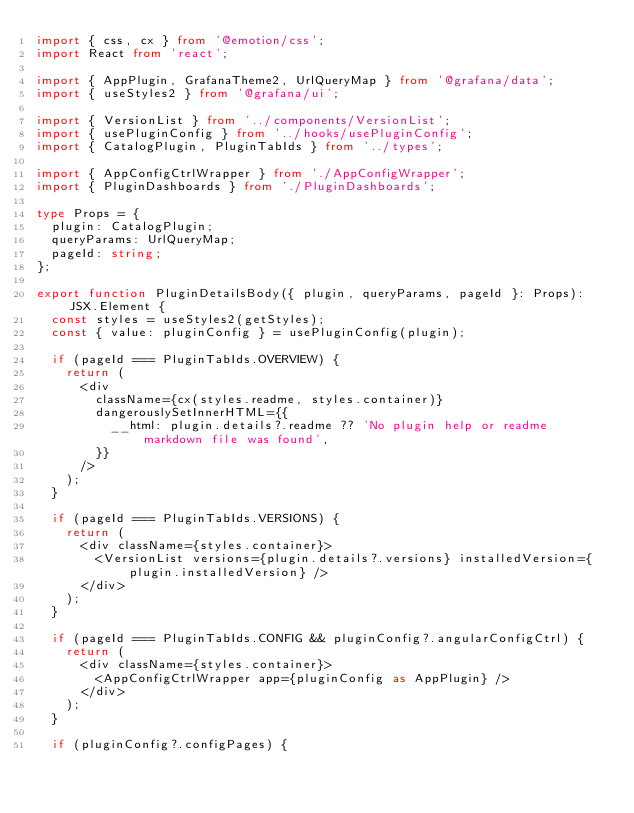Convert code to text. <code><loc_0><loc_0><loc_500><loc_500><_TypeScript_>import { css, cx } from '@emotion/css';
import React from 'react';

import { AppPlugin, GrafanaTheme2, UrlQueryMap } from '@grafana/data';
import { useStyles2 } from '@grafana/ui';

import { VersionList } from '../components/VersionList';
import { usePluginConfig } from '../hooks/usePluginConfig';
import { CatalogPlugin, PluginTabIds } from '../types';

import { AppConfigCtrlWrapper } from './AppConfigWrapper';
import { PluginDashboards } from './PluginDashboards';

type Props = {
  plugin: CatalogPlugin;
  queryParams: UrlQueryMap;
  pageId: string;
};

export function PluginDetailsBody({ plugin, queryParams, pageId }: Props): JSX.Element {
  const styles = useStyles2(getStyles);
  const { value: pluginConfig } = usePluginConfig(plugin);

  if (pageId === PluginTabIds.OVERVIEW) {
    return (
      <div
        className={cx(styles.readme, styles.container)}
        dangerouslySetInnerHTML={{
          __html: plugin.details?.readme ?? 'No plugin help or readme markdown file was found',
        }}
      />
    );
  }

  if (pageId === PluginTabIds.VERSIONS) {
    return (
      <div className={styles.container}>
        <VersionList versions={plugin.details?.versions} installedVersion={plugin.installedVersion} />
      </div>
    );
  }

  if (pageId === PluginTabIds.CONFIG && pluginConfig?.angularConfigCtrl) {
    return (
      <div className={styles.container}>
        <AppConfigCtrlWrapper app={pluginConfig as AppPlugin} />
      </div>
    );
  }

  if (pluginConfig?.configPages) {</code> 